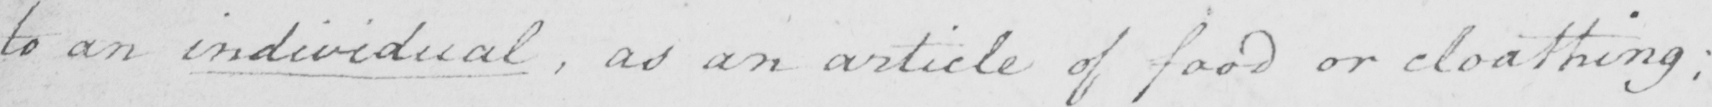Can you tell me what this handwritten text says? to an individual  , as an article of food or cloathing  ; 